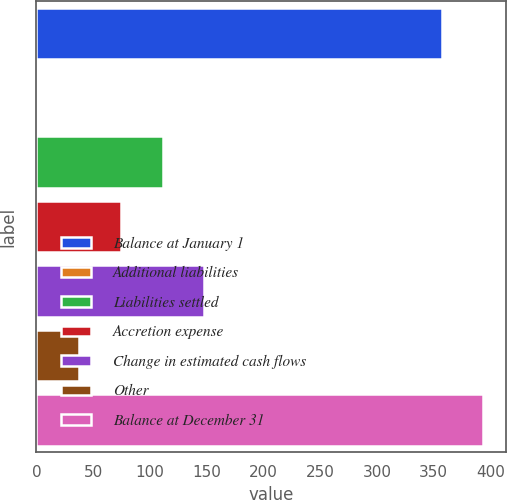Convert chart. <chart><loc_0><loc_0><loc_500><loc_500><bar_chart><fcel>Balance at January 1<fcel>Additional liabilities<fcel>Liabilities settled<fcel>Accretion expense<fcel>Change in estimated cash flows<fcel>Other<fcel>Balance at December 31<nl><fcel>357<fcel>1<fcel>111.1<fcel>74.4<fcel>147.8<fcel>37.7<fcel>393.7<nl></chart> 